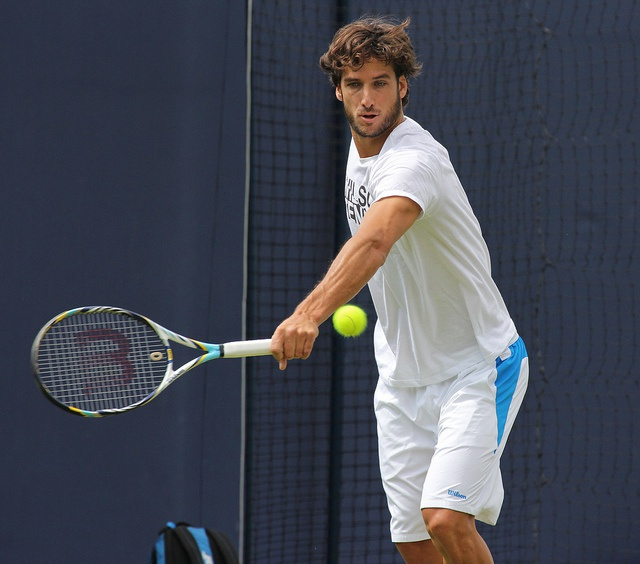Describe the objects in this image and their specific colors. I can see people in black, lightgray, darkgray, and brown tones, tennis racket in black, gray, and darkgray tones, backpack in black, gray, blue, and navy tones, and sports ball in black, yellow, khaki, and olive tones in this image. 